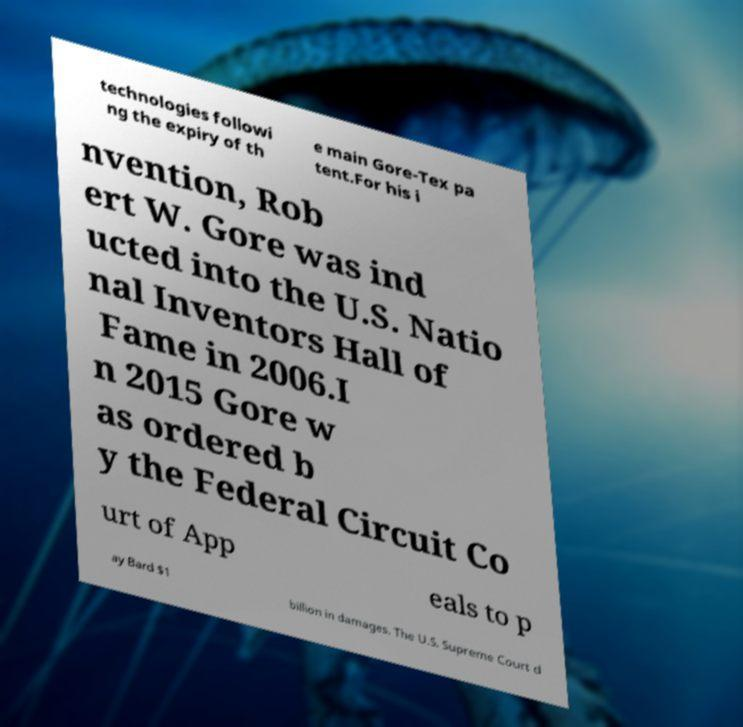For documentation purposes, I need the text within this image transcribed. Could you provide that? technologies followi ng the expiry of th e main Gore-Tex pa tent.For his i nvention, Rob ert W. Gore was ind ucted into the U.S. Natio nal Inventors Hall of Fame in 2006.I n 2015 Gore w as ordered b y the Federal Circuit Co urt of App eals to p ay Bard $1 billion in damages. The U.S. Supreme Court d 